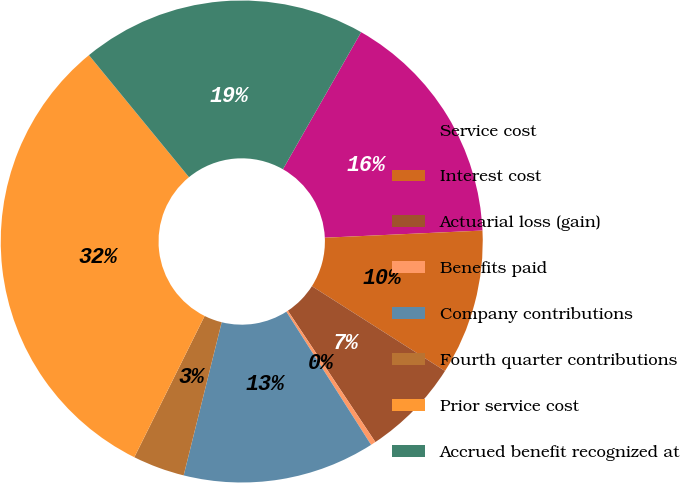Convert chart. <chart><loc_0><loc_0><loc_500><loc_500><pie_chart><fcel>Service cost<fcel>Interest cost<fcel>Actuarial loss (gain)<fcel>Benefits paid<fcel>Company contributions<fcel>Fourth quarter contributions<fcel>Prior service cost<fcel>Accrued benefit recognized at<nl><fcel>16.03%<fcel>9.75%<fcel>6.62%<fcel>0.34%<fcel>12.89%<fcel>3.48%<fcel>31.72%<fcel>19.18%<nl></chart> 